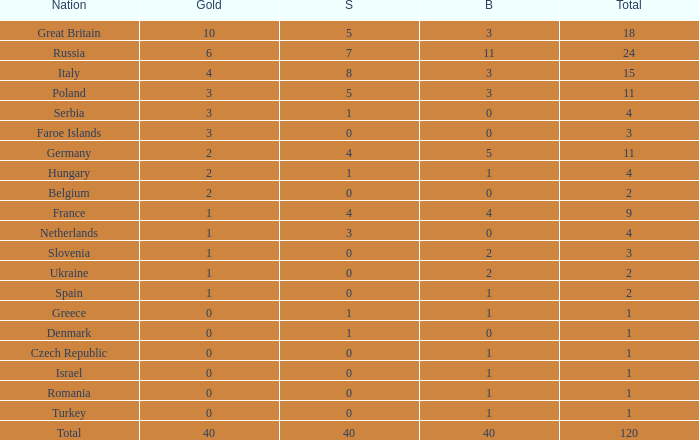What is Turkey's average Gold entry that also has a Bronze entry that is smaller than 2 and the Total is greater than 1? None. 